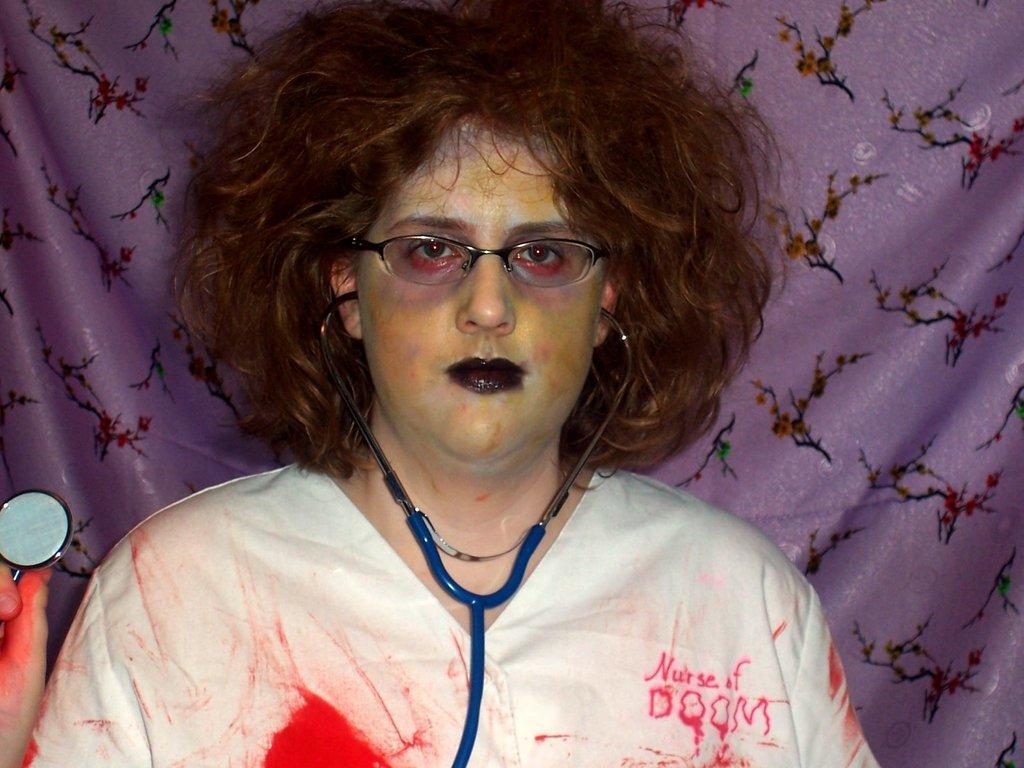Please provide a concise description of this image. In the image there is a woman inspects,stethoscope in white dress standing behind purple curtain. 